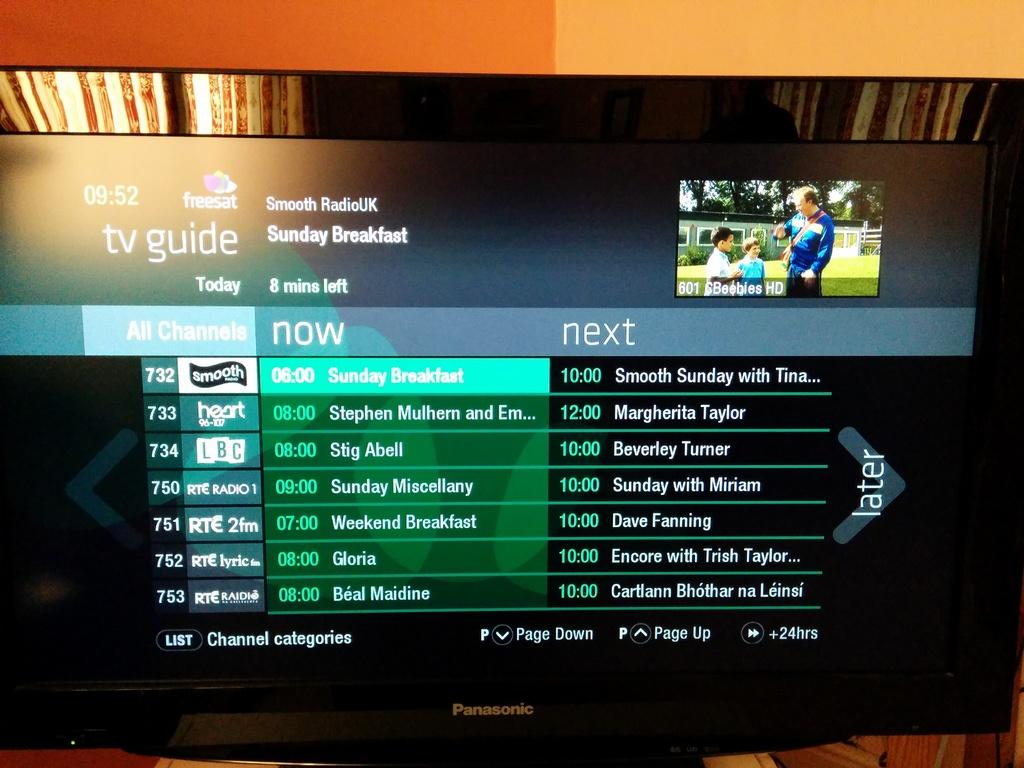<image>
Render a clear and concise summary of the photo. A television screen shows a tv guide with shows on now and the shows that are on next. 